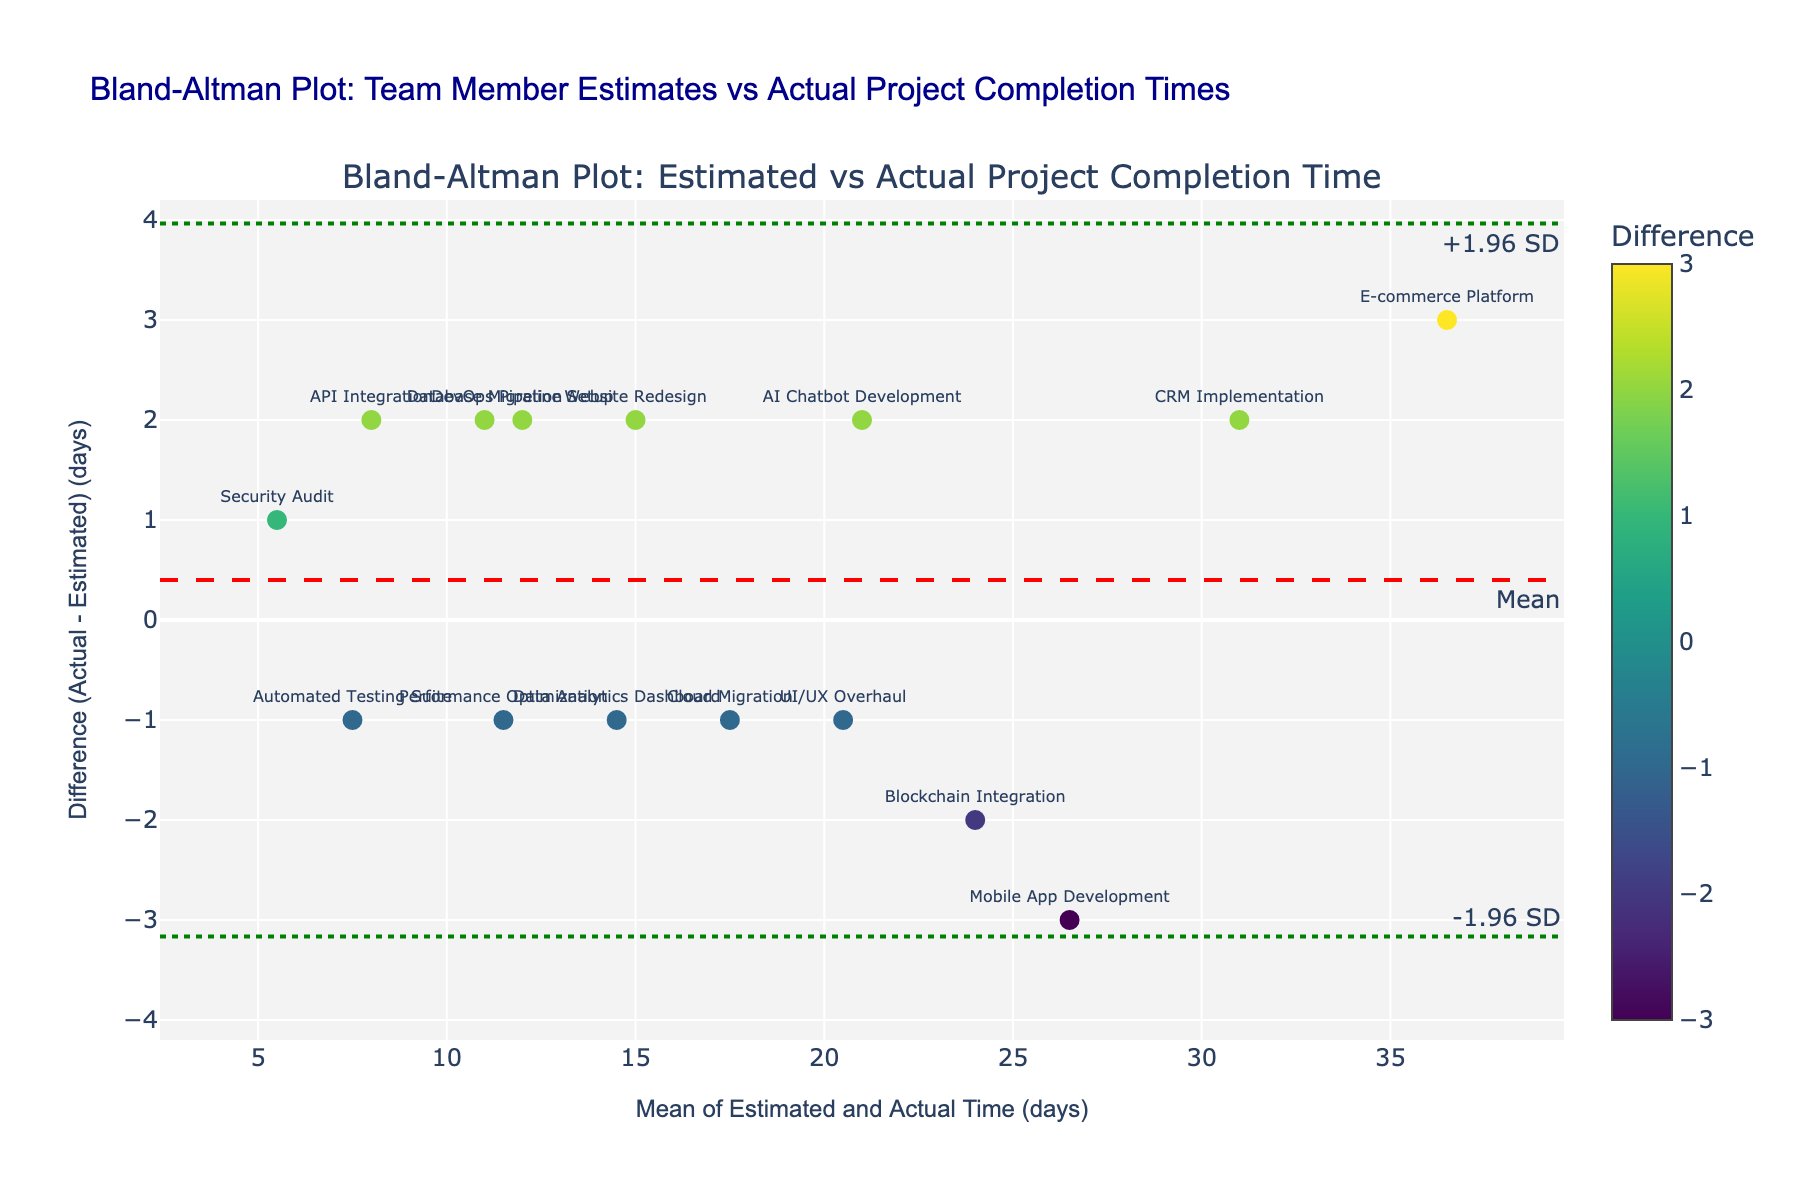How many projects are represented in the plot? Count the number of unique projects listed in the data used to generate the plot. Each marker corresponds to one project.
Answer: 15 What is the title of the plot? Look at the textual information provided at the top of the plot.
Answer: Bland-Altman Plot: Team Member Estimates vs Actual Project Completion Times What does the red dashed line represent? Identify the line in question and look for its label or annotation. This line is often used to indicate the mean difference between estimates and actuals.
Answer: The mean difference Which project has the largest positive difference between actual and estimated time? Locate the data point with the highest positive y-value (difference) and check its associated project name. Cross-reference this with the data labels or hover text in the plot.
Answer: E-commerce Platform Are there more positive differences or negative differences? Count the number of data points above the zero line (positive difference) and below the zero line (negative difference). Compare the counts to determine which is more.
Answer: More positive differences What is the range of the x-axis (Mean of Estimated and Actual Time)? Look at the values on the x-axis and determine the minimum and maximum values listed or the range they encompass.
Answer: Approximately from 5 to 36.5 What are the green dotted lines representing? Identify the color and pattern of the lines in question and match them with their labels or annotations. These lines generally indicate ±1.96 times the standard deviation from the mean.
Answer: ±1.96 standard deviations Which project has the smallest mean time between estimated and actual? Find the data point with the smallest x-value and note its associated project name. This can be cross-referenced by the hover text or data labels.
Answer: Security Audit What colorscale is used for the markers and what does it represent? Identify the color gradient applied to the data points and refer to the colorbar provided in the plot. The colors represent the magnitude of the difference.
Answer: Viridis, representing the difference in days Which projects have a difference exactly equal to 2 days? Locate the data points with a y-value of 2 and note the associated project names from the data labels or hover text.
Answer: Website Redesign, Database Migration, API Integration, CRM Implementation, AI Chatbot Development, DevOps Pipeline Setup 